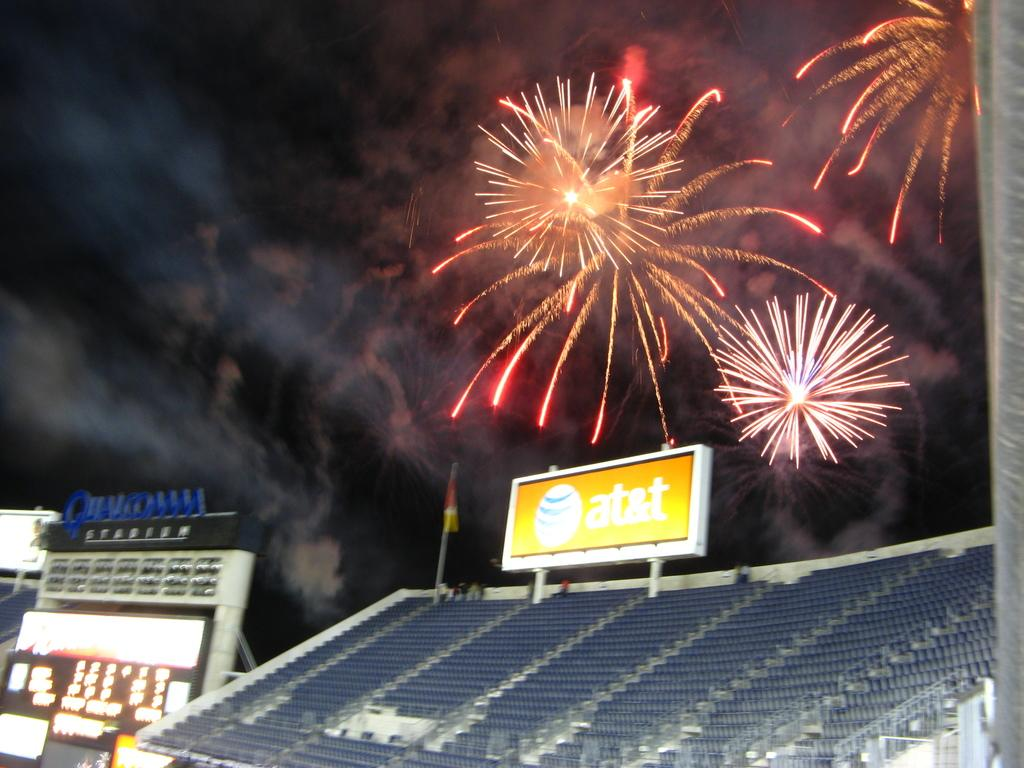<image>
Present a compact description of the photo's key features. Fireworks setting off at night behind Qualcomm Stadium. 